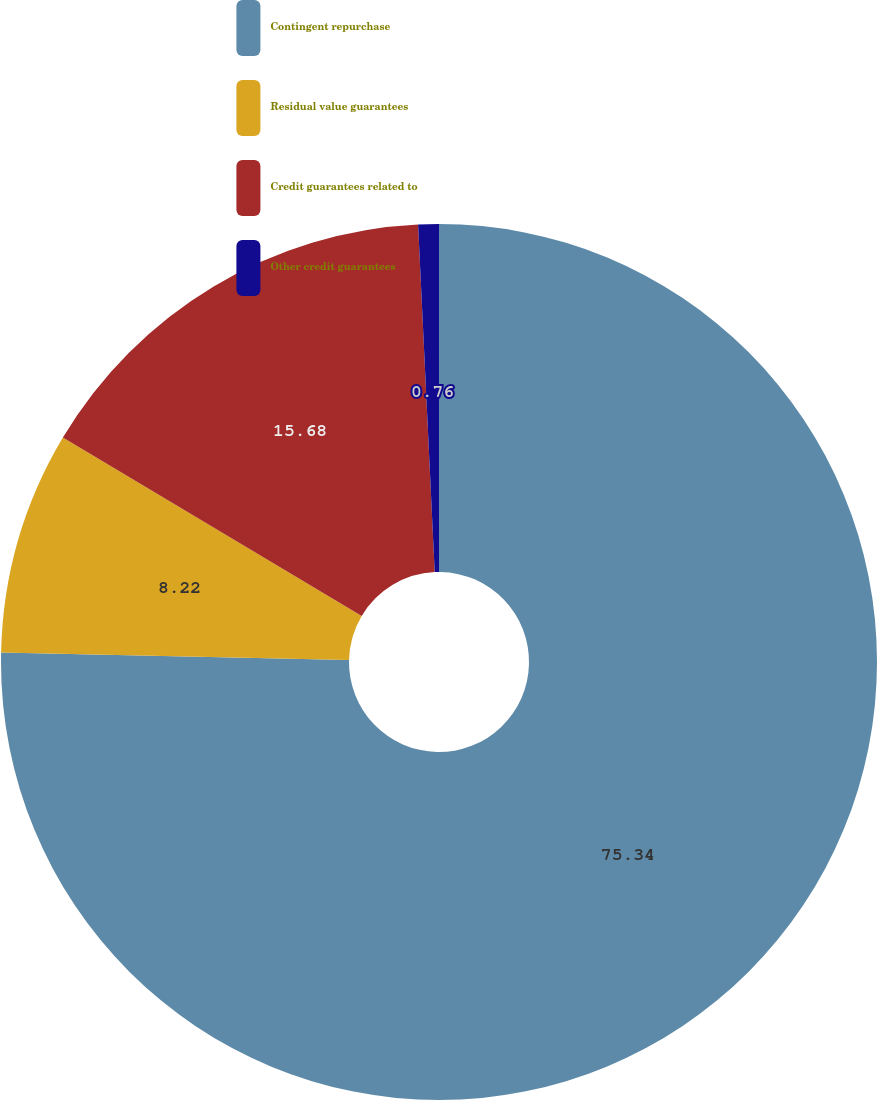Convert chart. <chart><loc_0><loc_0><loc_500><loc_500><pie_chart><fcel>Contingent repurchase<fcel>Residual value guarantees<fcel>Credit guarantees related to<fcel>Other credit guarantees<nl><fcel>75.35%<fcel>8.22%<fcel>15.68%<fcel>0.76%<nl></chart> 